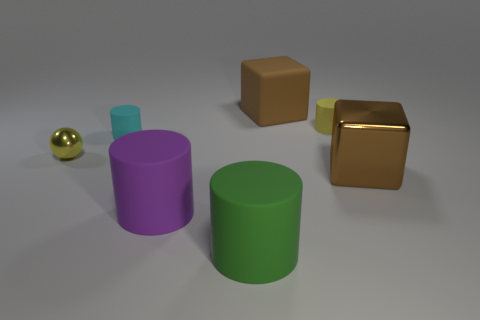How large is the purple cylinder compared to the green cylinder? The purple cylinder is slightly larger than the green cylinder, with a more substantial height that gives it a dominant presence in the scene. 